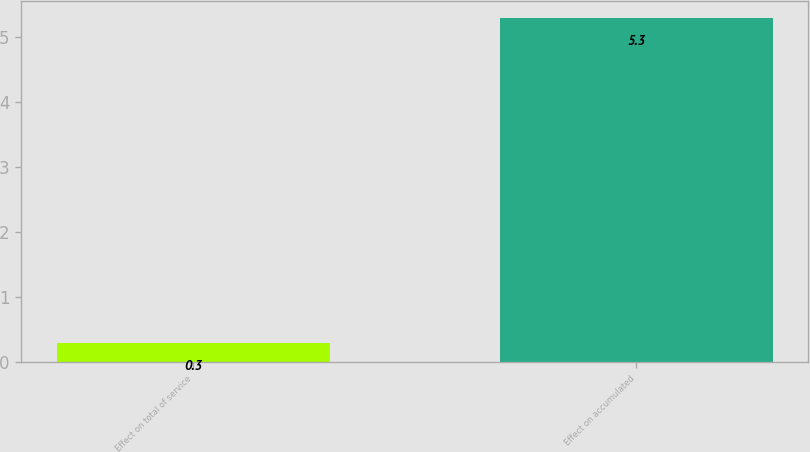Convert chart. <chart><loc_0><loc_0><loc_500><loc_500><bar_chart><fcel>Effect on total of service<fcel>Effect on accumulated<nl><fcel>0.3<fcel>5.3<nl></chart> 